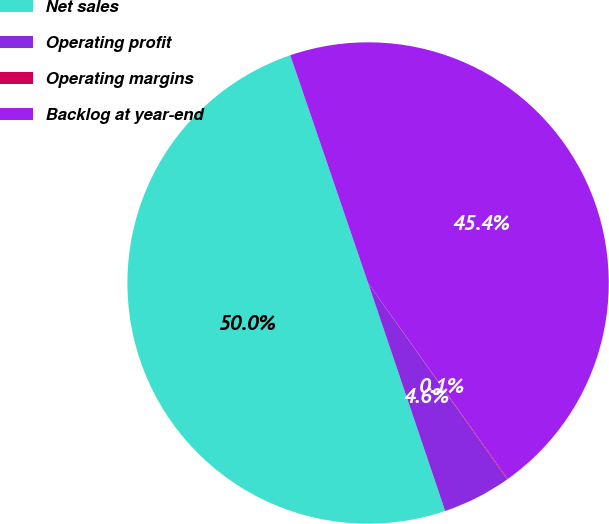Convert chart. <chart><loc_0><loc_0><loc_500><loc_500><pie_chart><fcel>Net sales<fcel>Operating profit<fcel>Operating margins<fcel>Backlog at year-end<nl><fcel>49.95%<fcel>4.62%<fcel>0.05%<fcel>45.38%<nl></chart> 